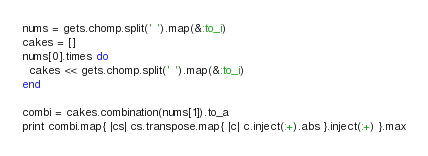<code> <loc_0><loc_0><loc_500><loc_500><_Ruby_>nums = gets.chomp.split(' ').map(&:to_i)
cakes = []
nums[0].times do
  cakes << gets.chomp.split(' ').map(&:to_i)
end

combi = cakes.combination(nums[1]).to_a
print combi.map{ |cs| cs.transpose.map{ |c| c.inject(:+).abs }.inject(:+) }.max
</code> 